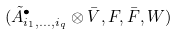Convert formula to latex. <formula><loc_0><loc_0><loc_500><loc_500>( \tilde { A } ^ { \bullet } _ { i _ { 1 } , \dots , i _ { q } } \otimes \bar { V } , F , \bar { F } , W )</formula> 